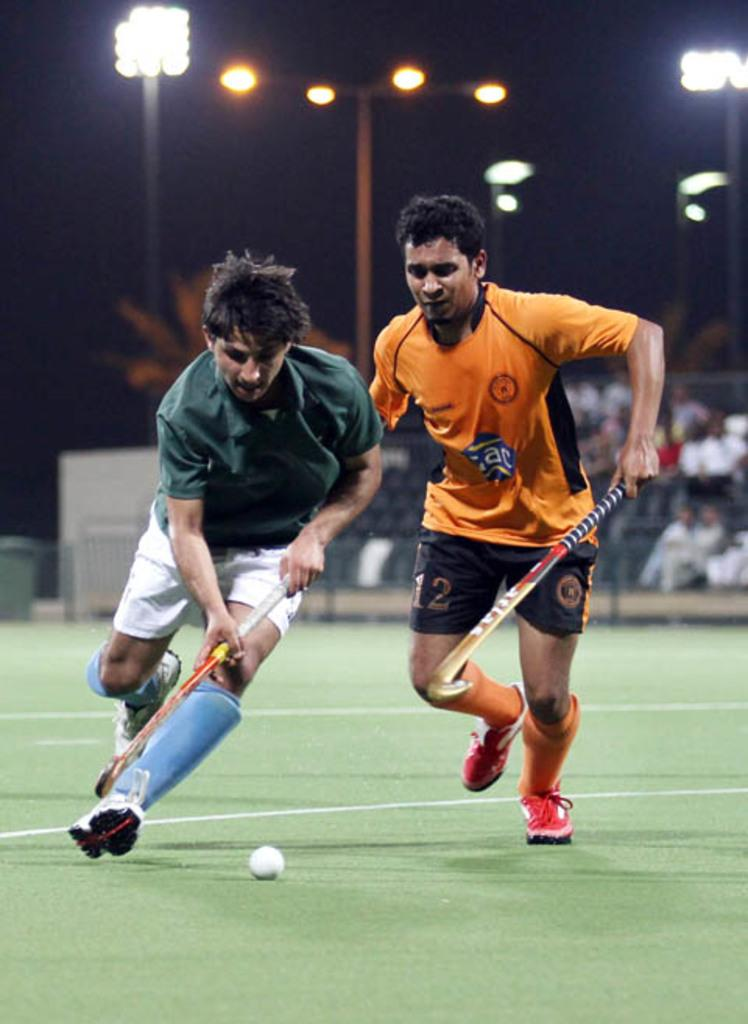<image>
Present a compact description of the photo's key features. Two lacross players, one of them with black shorts with the number 12 written on them 